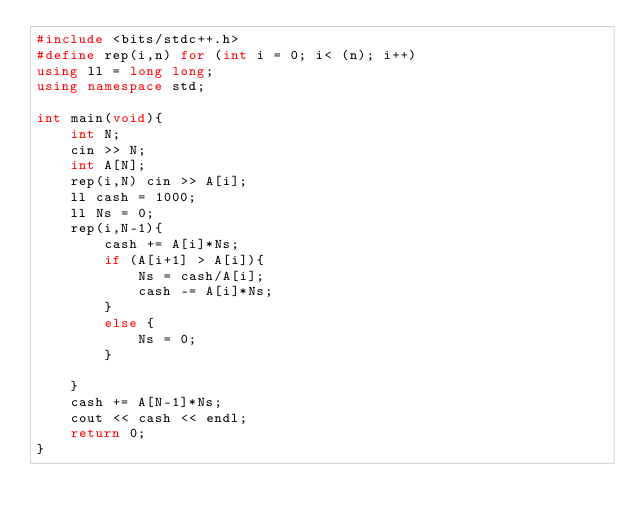<code> <loc_0><loc_0><loc_500><loc_500><_C++_>#include <bits/stdc++.h>
#define rep(i,n) for (int i = 0; i< (n); i++)
using ll = long long;
using namespace std;

int main(void){
	int N;
	cin >> N;
	int A[N];
	rep(i,N) cin >> A[i];
	ll cash = 1000;
	ll Ns = 0;
	rep(i,N-1){
		cash += A[i]*Ns;
		if (A[i+1] > A[i]){
			Ns = cash/A[i];
			cash -= A[i]*Ns;
		}
		else {
			Ns = 0;
		}

	}
	cash += A[N-1]*Ns;
	cout << cash << endl;
	return 0;
}
</code> 